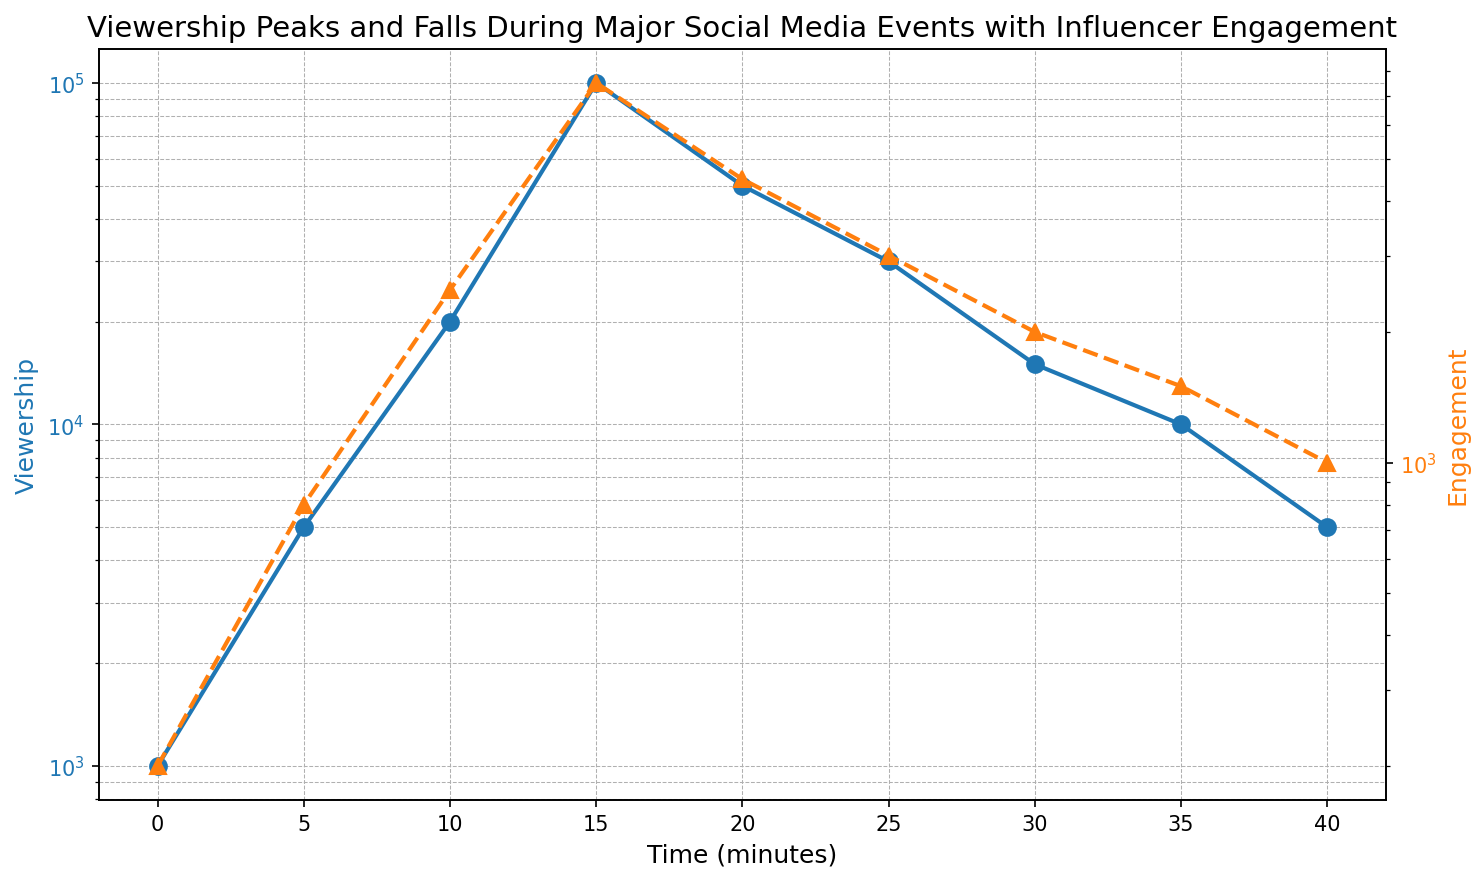Which event has the highest peak in viewership? By examining the viewership data on the y-axis in a log scale, we can see that "Stunt Execution" shows the highest peak in viewership.
Answer: Stunt Execution During which time interval does the most significant drop in viewership occur? From the log-scaled graph, viewership drops dramatically between "Stunt Execution" (15 minutes) and "Initial Reaction" (20 minutes).
Answer: 15 to 20 minutes How does engagement change relative to viewership immediately after the "Stunt Execution"? Post "Stunt Execution", viewership drops from 100,000 to 50,000, but engagement drops less sharply from 7500 to 4500. This indicates that engagement remains relatively higher than the viewership.
Answer: Engagement drops less sharply What is the ratio of viewership to engagement at its peak? At "Stunt Execution", viewership is 100,000 and engagement is 7500. The ratio is calculated by dividing viewership by engagement.
Answer: 13.33 Compare the viewership at "Stunt Build-Up" and "Post-Event Recap". Which is higher and by how much? "Stunt Build-Up" has 20,000 viewership while "Post-Event Recap" has 10,000 viewership. The difference between them is 20,000 - 10,000.
Answer: 10,000 higher What trend do you observe for both viewership and engagement between "Event Cool-down" and "Viewer Drop-off"? Both viewership and engagement see a decline between "Event Cool-down" and "Viewer Drop-off". Viewership drops from 30,000 to 15,000, and engagement falls from 3,000 to 2,000, indicating a downward trend.
Answer: Downward trend Which event shows the smallest difference between viewership and engagement? By evaluating each event, "End of Event" shows a viewership of 5,000 and engagement of 1,000, making the smallest difference in absolute terms (4,000).
Answer: End of Event What is the average viewership during the event? Sum the viewership values: 1000 + 5000 + 20000 + 100000 + 50000 + 30000 + 15000 + 10000 + 5000 = 236,000. Divide this by the number of events (9).
Answer: 26,222 What is the trend for viewership and engagement from "Initial Reaction" to "Event Cool-down"? Viewing the graph, both viewership and engagement are seen to decline from "Initial Reaction" (50,000 and 4500) to "Event Cool-down" (30,000 and 3000).
Answer: Decline How does the time of the "Post-Event Recap" compare to "Stunt Execution" in terms of engagement? Engagement at "Post-Event Recap" is 1,500 while at "Stunt Execution" it is 7,500. This shows a significant decrease by 6,000.
Answer: 6,000 lower 